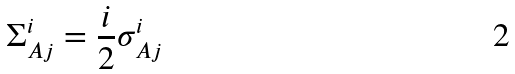<formula> <loc_0><loc_0><loc_500><loc_500>\Sigma _ { A j } ^ { i } = \frac { i } { 2 } \sigma _ { A j } ^ { i }</formula> 